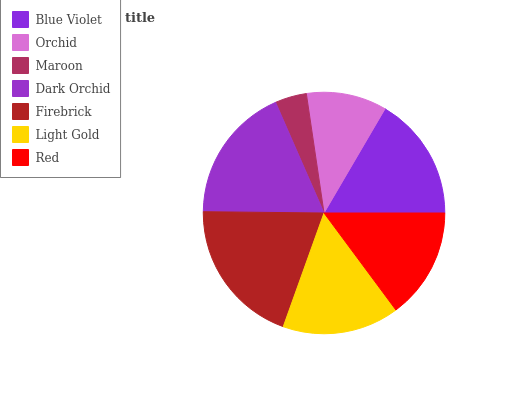Is Maroon the minimum?
Answer yes or no. Yes. Is Firebrick the maximum?
Answer yes or no. Yes. Is Orchid the minimum?
Answer yes or no. No. Is Orchid the maximum?
Answer yes or no. No. Is Blue Violet greater than Orchid?
Answer yes or no. Yes. Is Orchid less than Blue Violet?
Answer yes or no. Yes. Is Orchid greater than Blue Violet?
Answer yes or no. No. Is Blue Violet less than Orchid?
Answer yes or no. No. Is Light Gold the high median?
Answer yes or no. Yes. Is Light Gold the low median?
Answer yes or no. Yes. Is Blue Violet the high median?
Answer yes or no. No. Is Red the low median?
Answer yes or no. No. 